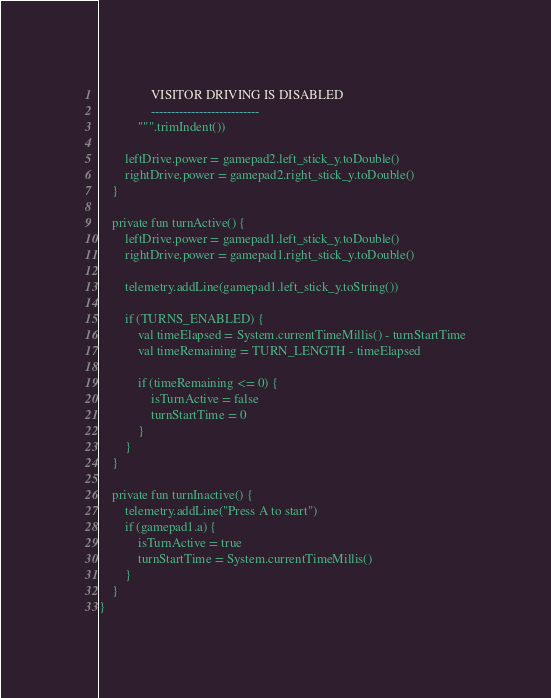<code> <loc_0><loc_0><loc_500><loc_500><_Kotlin_>                VISITOR DRIVING IS DISABLED
                ---------------------------
            """.trimIndent())

        leftDrive.power = gamepad2.left_stick_y.toDouble()
        rightDrive.power = gamepad2.right_stick_y.toDouble()
    }

    private fun turnActive() {
        leftDrive.power = gamepad1.left_stick_y.toDouble()
        rightDrive.power = gamepad1.right_stick_y.toDouble()

        telemetry.addLine(gamepad1.left_stick_y.toString())

        if (TURNS_ENABLED) {
            val timeElapsed = System.currentTimeMillis() - turnStartTime
            val timeRemaining = TURN_LENGTH - timeElapsed

            if (timeRemaining <= 0) {
                isTurnActive = false
                turnStartTime = 0
            }
        }
    }

    private fun turnInactive() {
        telemetry.addLine("Press A to start")
        if (gamepad1.a) {
            isTurnActive = true
            turnStartTime = System.currentTimeMillis()
        }
    }
}</code> 